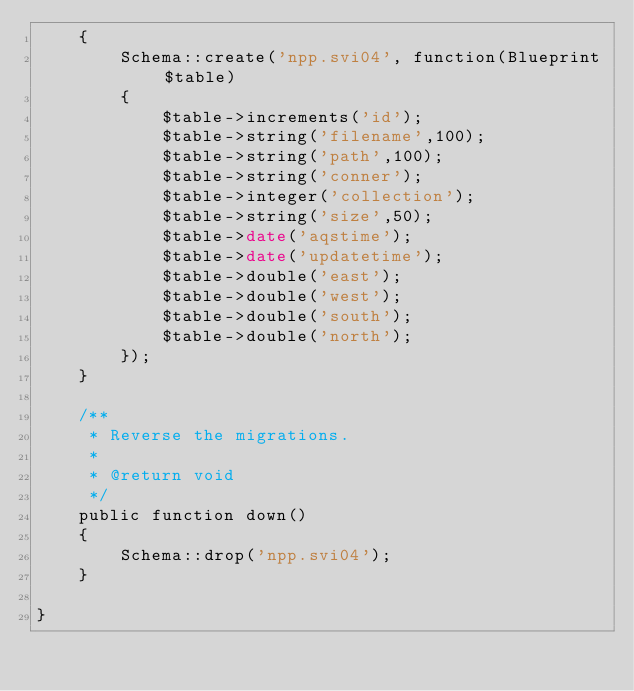<code> <loc_0><loc_0><loc_500><loc_500><_PHP_>	{
		Schema::create('npp.svi04', function(Blueprint $table)
		{
			$table->increments('id');
	        $table->string('filename',100);
	        $table->string('path',100);
	        $table->string('conner');
	        $table->integer('collection');
	        $table->string('size',50);
	        $table->date('aqstime');
	        $table->date('updatetime');
	        $table->double('east');
	        $table->double('west');
	        $table->double('south');
	        $table->double('north');
		});
	}

	/**
	 * Reverse the migrations.
	 *
	 * @return void
	 */
	public function down()
	{
		Schema::drop('npp.svi04');
	}

}
</code> 